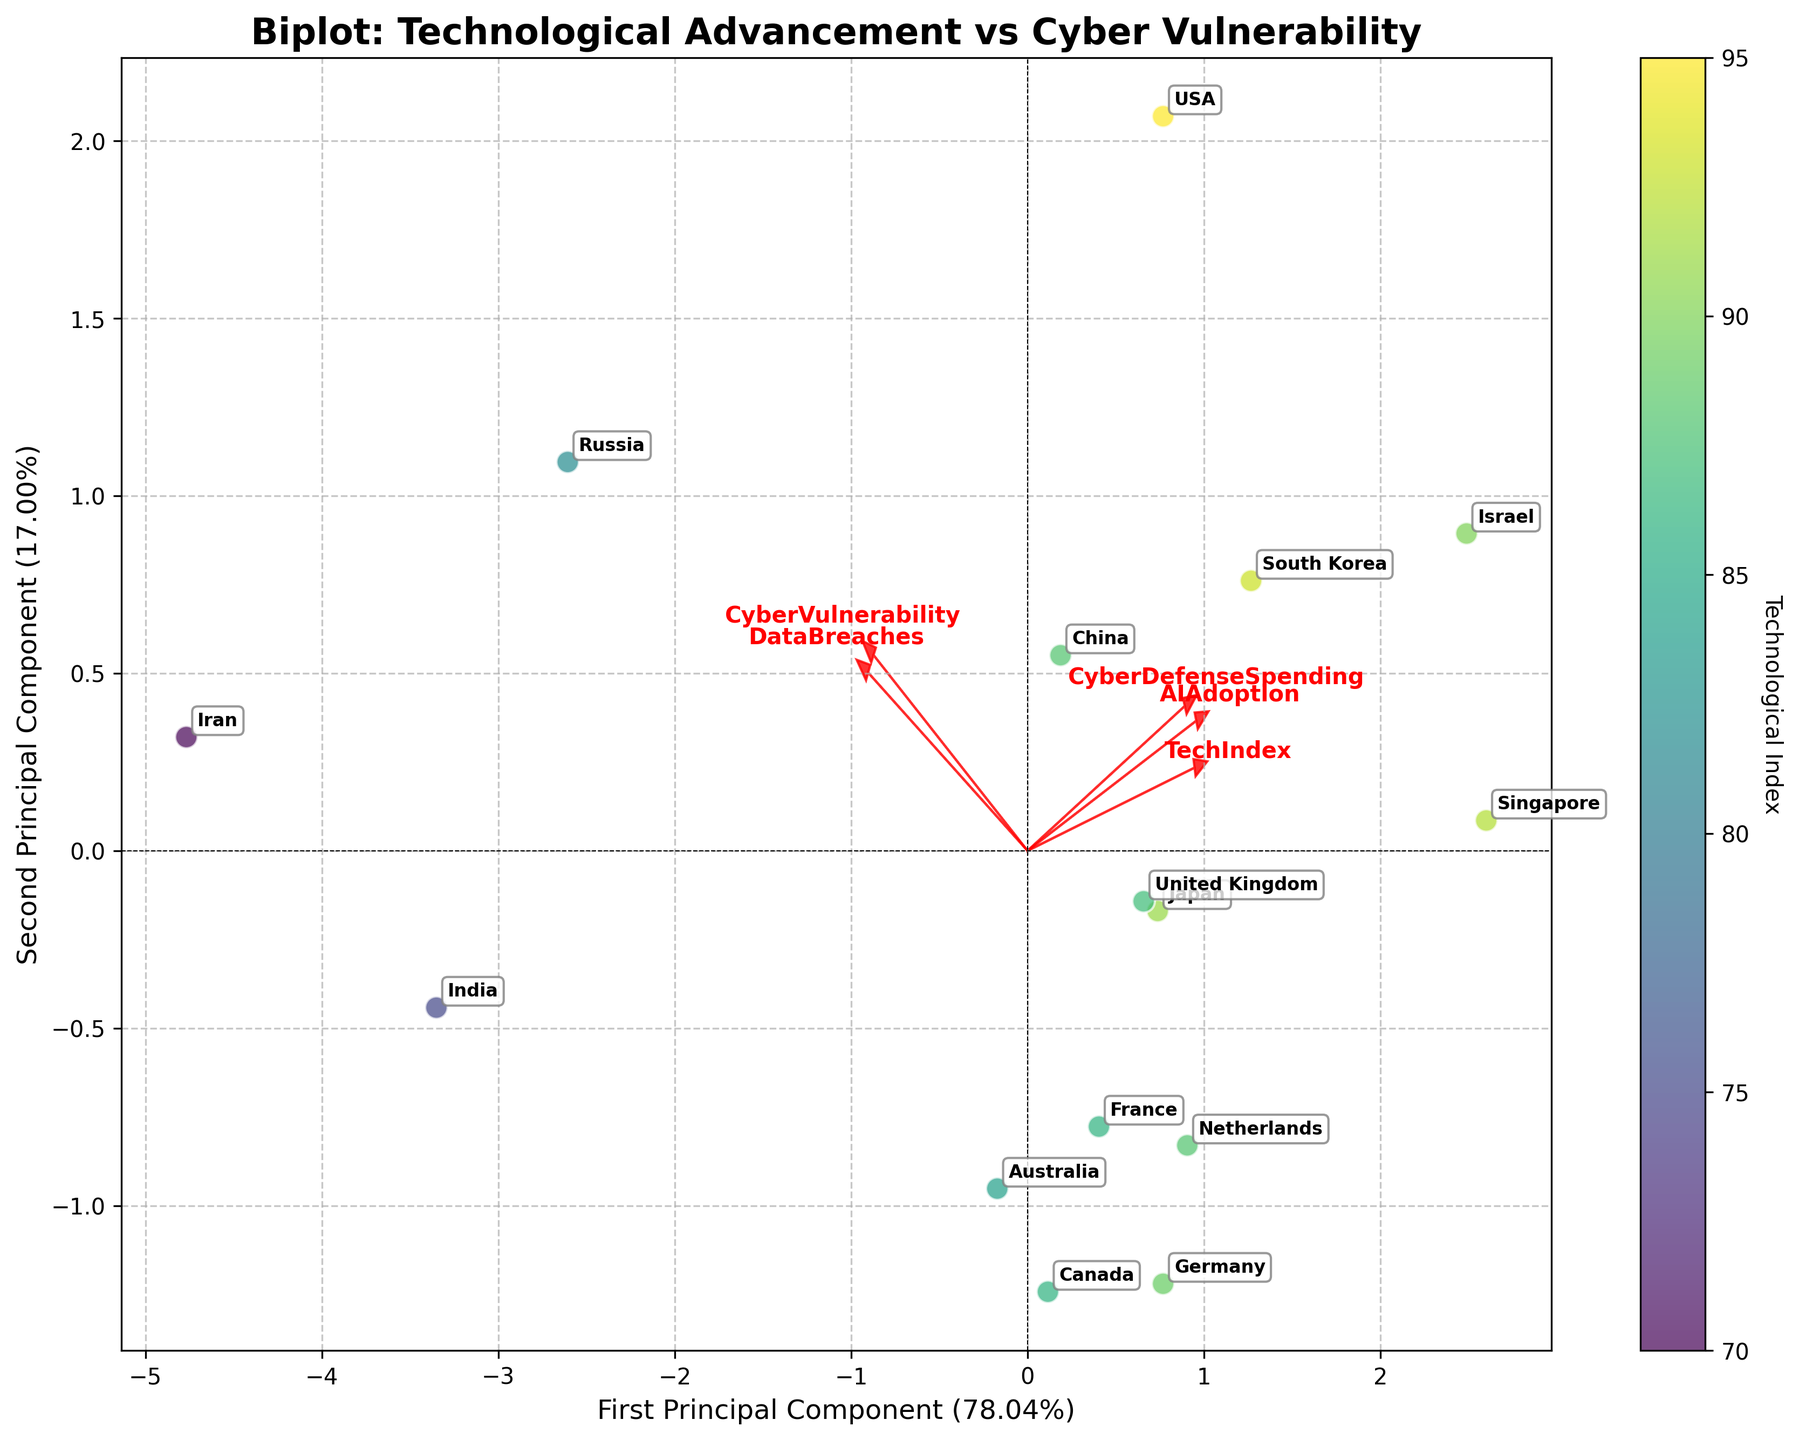What variables are represented by the arrows in the plot? The arrows in the biplot represent the features 'TechIndex', 'CyberVulnerability', 'CyberDefenseSpending', 'DataBreaches', and 'AIAdoption'. These arrows indicate how much each feature contributes to the principal components and their direction.
Answer: 'TechIndex', 'CyberVulnerability', 'CyberDefenseSpending', 'DataBreaches', 'AIAdoption' Which country has the highest technological index according to the color intensity? The color intensity represents the technological index, and the country with the highest intensity (darkest color) is the USA.
Answer: USA Is there a visible relationship between technologies such as AI adoption and cyber vulnerability in the plot? By examining the direction and length of the arrows, we can infer the relationship. The arrows for 'AIAdoption' and 'CyberVulnerability' don't align closely, indicating that higher AI adoption does not necessarily correlate with higher cyber vulnerability.
Answer: No strong relationship Which features most strongly correlate with the first principal component? The arrows representing the loadings indicate this. The 'TechIndex' and 'AIAdoption' arrows appear longest and almost parallel to the first principal component axis, implying they are the most correlated.
Answer: 'TechIndex', 'AIAdoption' How do the technological advancements of Iran and Israel compare on the biplot? By observing the scatter plot, Iran and Israel are positioned quite far apart. Israel has a much higher technological advancement score (closer to the right side) compared to Iran.
Answer: Israel higher Which two countries appear closest together in the plot? By visually checking the biplot, the countries with the nearest position to each other are Germany and United Kingdom.
Answer: Germany and United Kingdom Based on the biplot, how would you describe the position of the USA relative to other countries? The USA is situated at the top-right quadrant of the plot, indicating high technological advancement (high TechIndex) and moderate cyber vulnerability.
Answer: Top-right quadrant, high TechIndex What can be inferred about the relationship between cyber defense spending and data breaches? The arrows for 'CyberDefenseSpending' and 'DataBreaches' point in different directions on the biplot, suggesting a negative correlation; countries with higher cyber defense spending tend to experience fewer data breaches.
Answer: Negative correlation What's the explained variance by the first and second principal components? The axis labels in the biplot indicate the explained variance. The first principal component explains around 46%, and the second explains approximately 21%.
Answer: 46%, 21% 